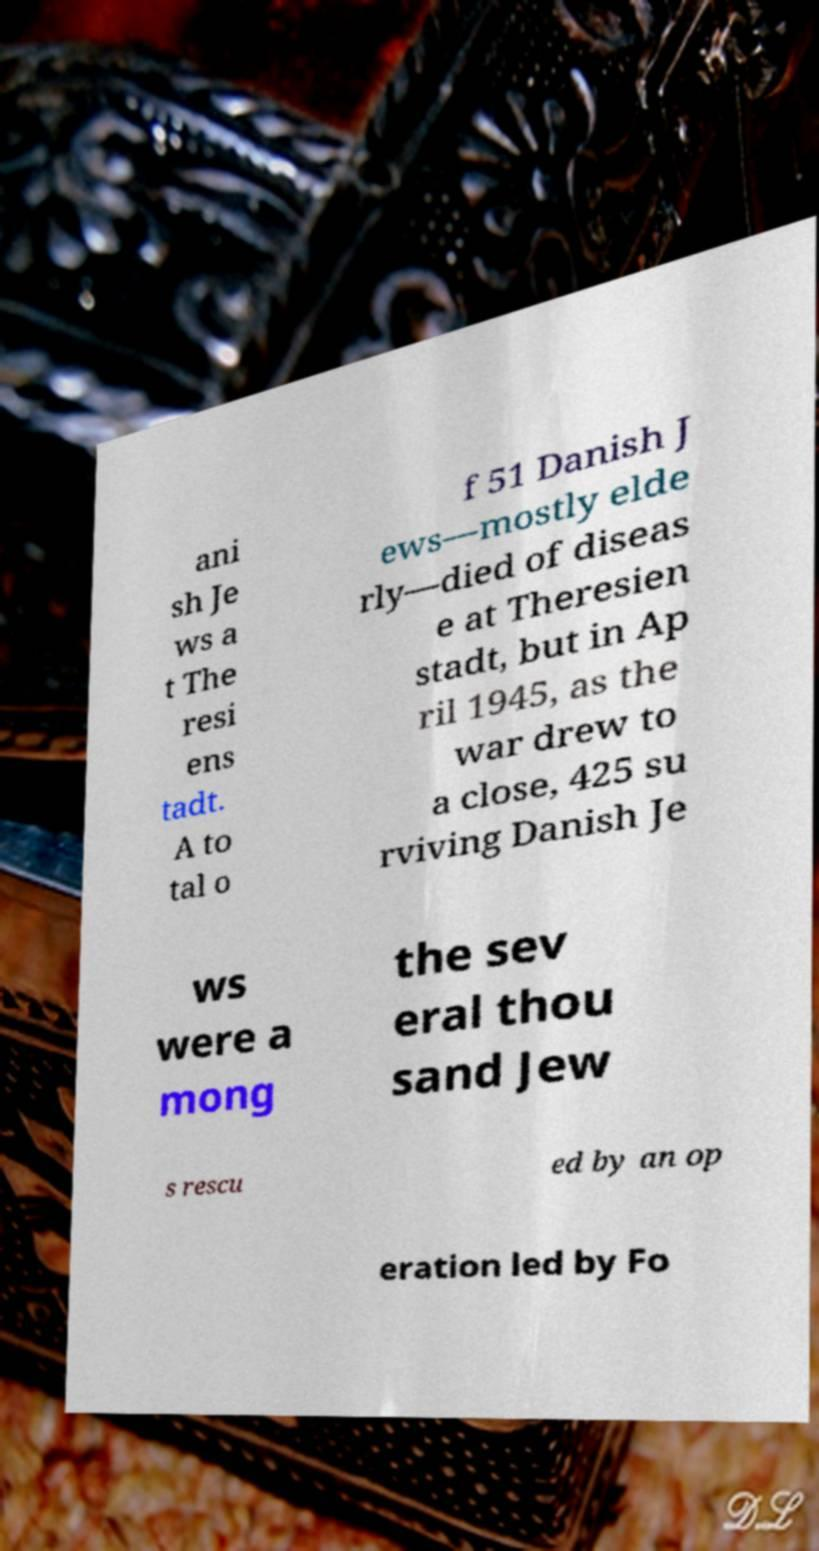Please read and relay the text visible in this image. What does it say? ani sh Je ws a t The resi ens tadt. A to tal o f 51 Danish J ews—mostly elde rly—died of diseas e at Theresien stadt, but in Ap ril 1945, as the war drew to a close, 425 su rviving Danish Je ws were a mong the sev eral thou sand Jew s rescu ed by an op eration led by Fo 